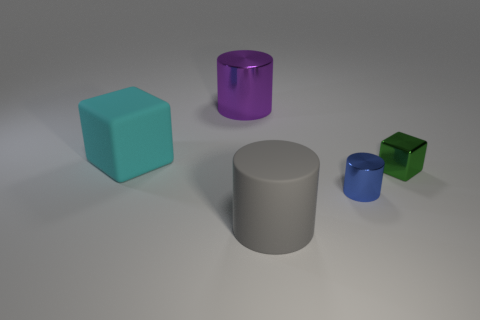Add 3 gray things. How many objects exist? 8 Subtract all cylinders. How many objects are left? 2 Subtract all big gray metallic things. Subtract all purple cylinders. How many objects are left? 4 Add 4 large matte cubes. How many large matte cubes are left? 5 Add 2 gray rubber objects. How many gray rubber objects exist? 3 Subtract 0 yellow cylinders. How many objects are left? 5 